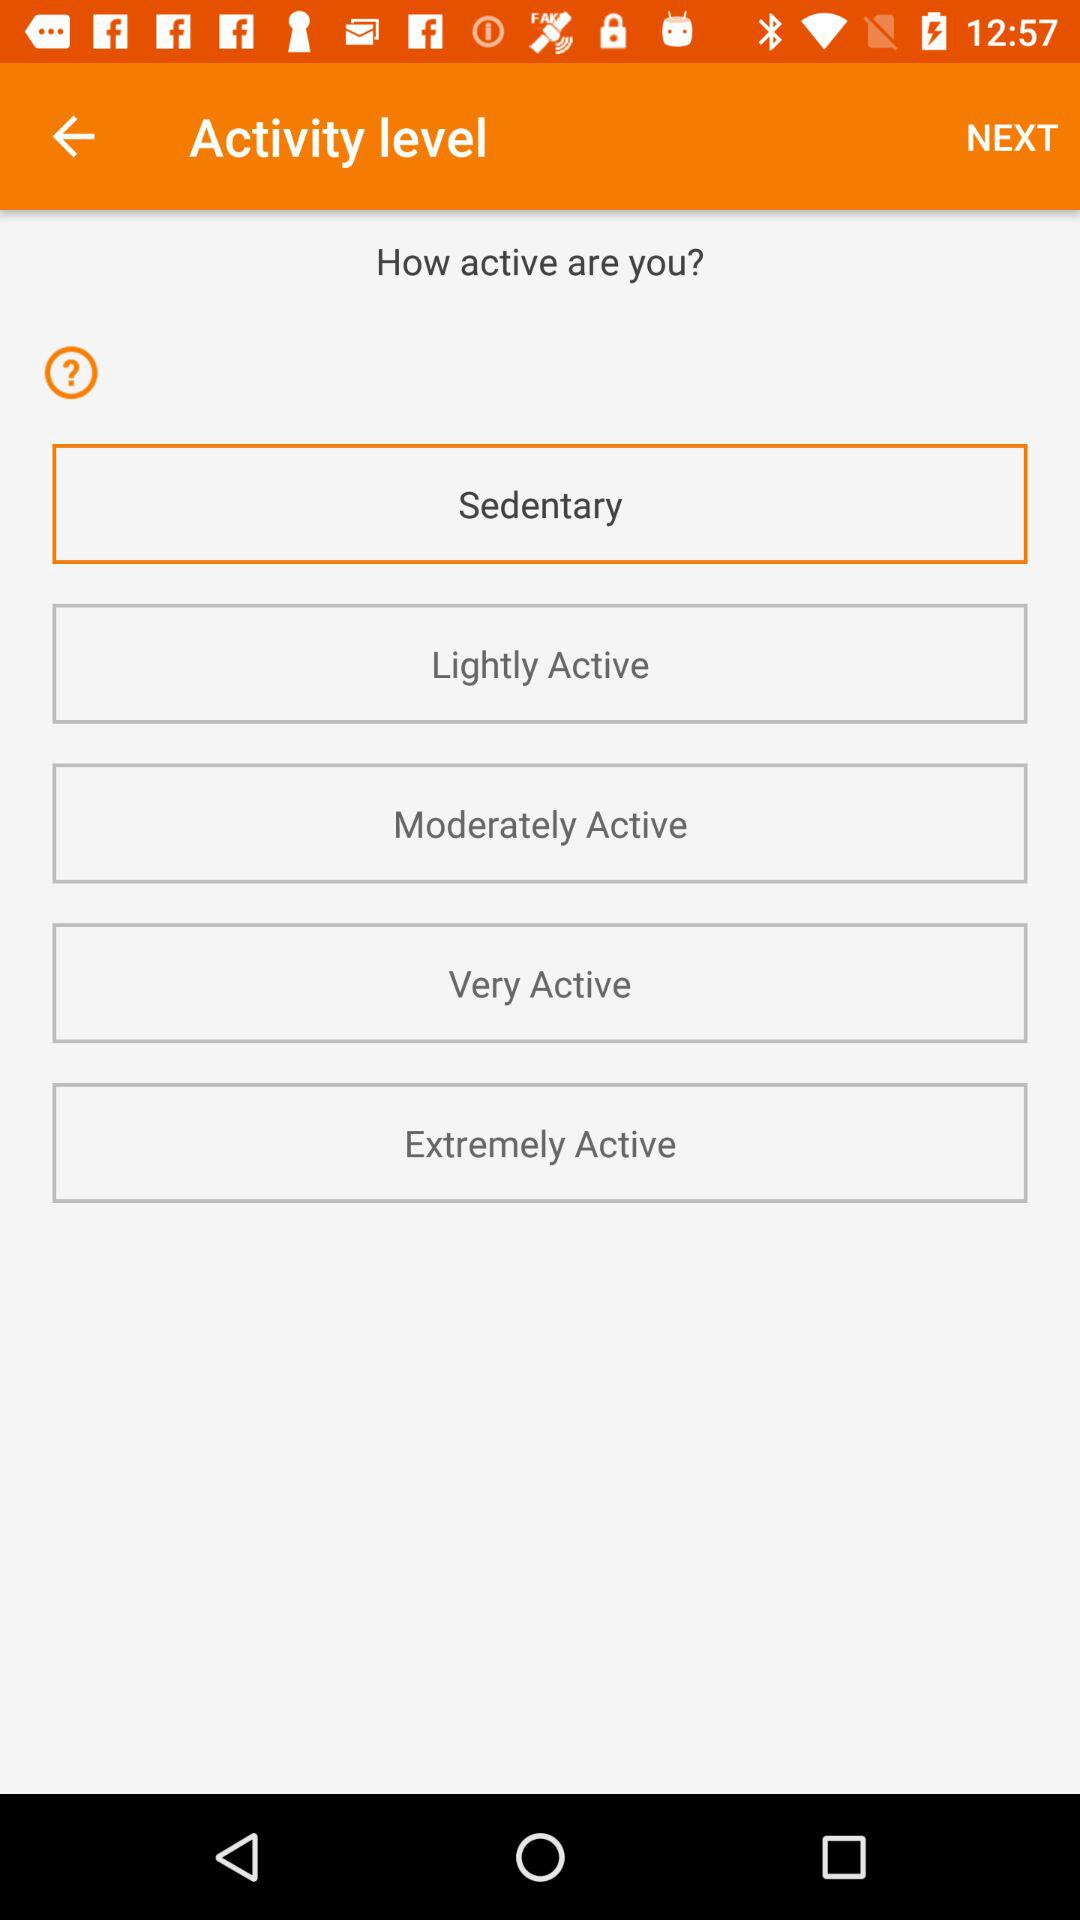What are the different available activity levels? The different available activity levels are "Sedentary", "Lightly Active", "Moderately Active", "Very Active" and "Extremely Active". 